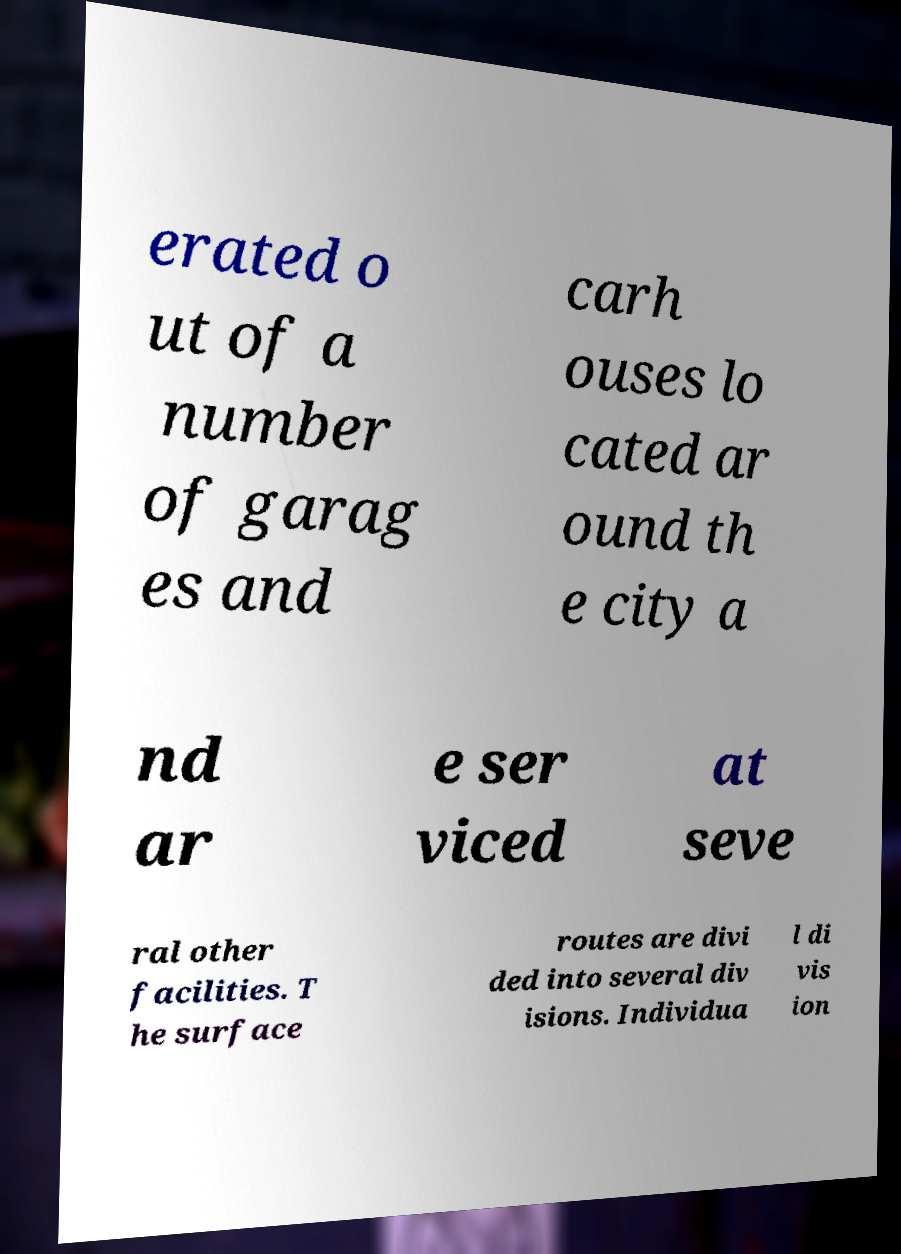There's text embedded in this image that I need extracted. Can you transcribe it verbatim? erated o ut of a number of garag es and carh ouses lo cated ar ound th e city a nd ar e ser viced at seve ral other facilities. T he surface routes are divi ded into several div isions. Individua l di vis ion 